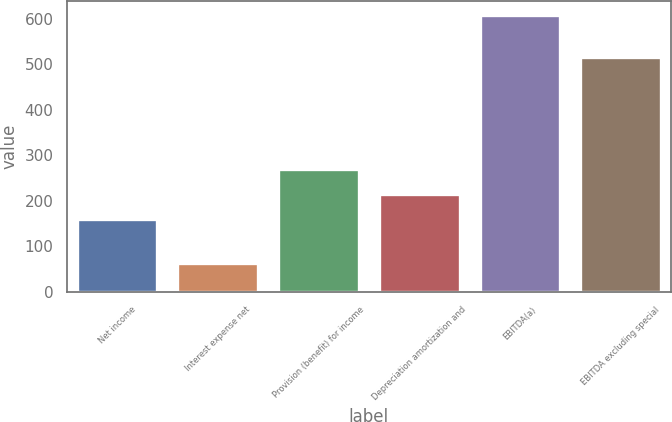<chart> <loc_0><loc_0><loc_500><loc_500><bar_chart><fcel>Net income<fcel>Interest expense net<fcel>Provision (benefit) for income<fcel>Depreciation amortization and<fcel>EBITDA(a)<fcel>EBITDA excluding special<nl><fcel>160.2<fcel>62.9<fcel>269.3<fcel>214.75<fcel>608.4<fcel>514.9<nl></chart> 